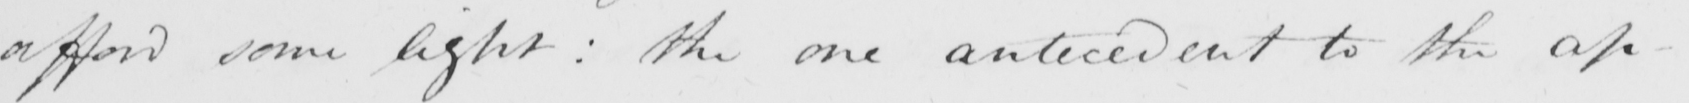Please provide the text content of this handwritten line. afford some light :  the one antecedent to the ap- 